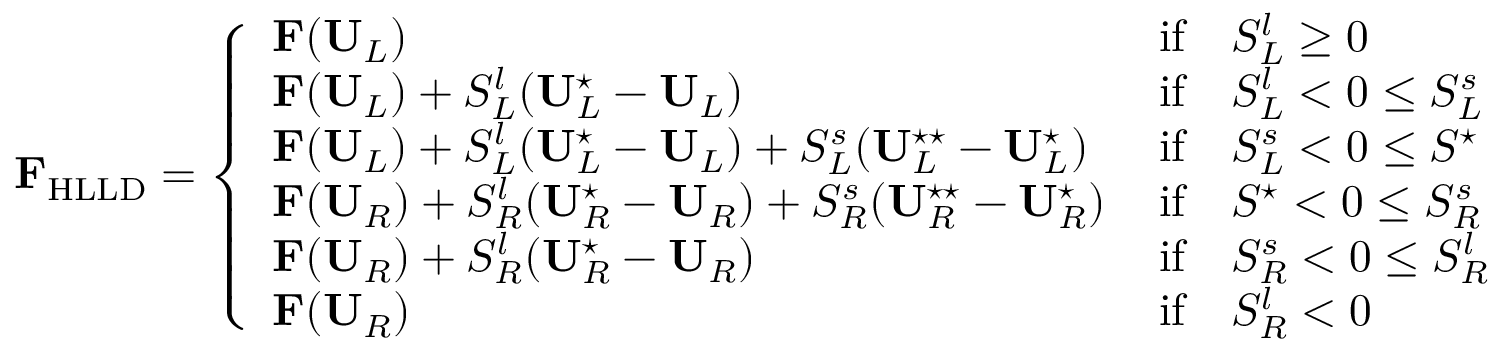<formula> <loc_0><loc_0><loc_500><loc_500>F _ { H L L D } = \left \{ \begin{array} { l l } { F ( U _ { L } ) \, } & { i f \quad S _ { L } ^ { l } \geq 0 } \\ { F ( U _ { L } ) + S _ { L } ^ { l } ( U _ { L } ^ { ^ { * } } - U _ { L } ) \, } & { i f \quad S _ { L } ^ { l } < 0 \leq S _ { L } ^ { s } } \\ { F ( U _ { L } ) + S _ { L } ^ { l } ( U _ { L } ^ { ^ { * } } - U _ { L } ) + S _ { L } ^ { s } ( U _ { L } ^ { ^ { * } ^ { * } } - U _ { L } ^ { ^ { * } } ) \, } & { i f \quad S _ { L } ^ { s } < 0 \leq S ^ { ^ { * } } } \\ { F ( U _ { R } ) + S _ { R } ^ { l } ( U _ { R } ^ { ^ { * } } - U _ { R } ) + S _ { R } ^ { s } ( U _ { R } ^ { ^ { * } ^ { * } } - U _ { R } ^ { ^ { * } } ) \, } & { i f \quad S ^ { ^ { * } } < 0 \leq S _ { R } ^ { s } } \\ { F ( U _ { R } ) + S _ { R } ^ { l } ( U _ { R } ^ { ^ { * } } - U _ { R } ) \, } & { i f \quad S _ { R } ^ { s } < 0 \leq S _ { R } ^ { l } } \\ { F ( U _ { R } ) \, } & { i f \quad S _ { R } ^ { l } < 0 } \end{array}</formula> 